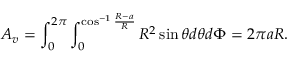<formula> <loc_0><loc_0><loc_500><loc_500>A _ { v } = \int _ { 0 } ^ { 2 \pi } \int _ { 0 } ^ { \cos ^ { - 1 } { \frac { R - a } { R } } } R ^ { 2 } \sin { \theta } d \theta d \Phi = 2 \pi a R .</formula> 